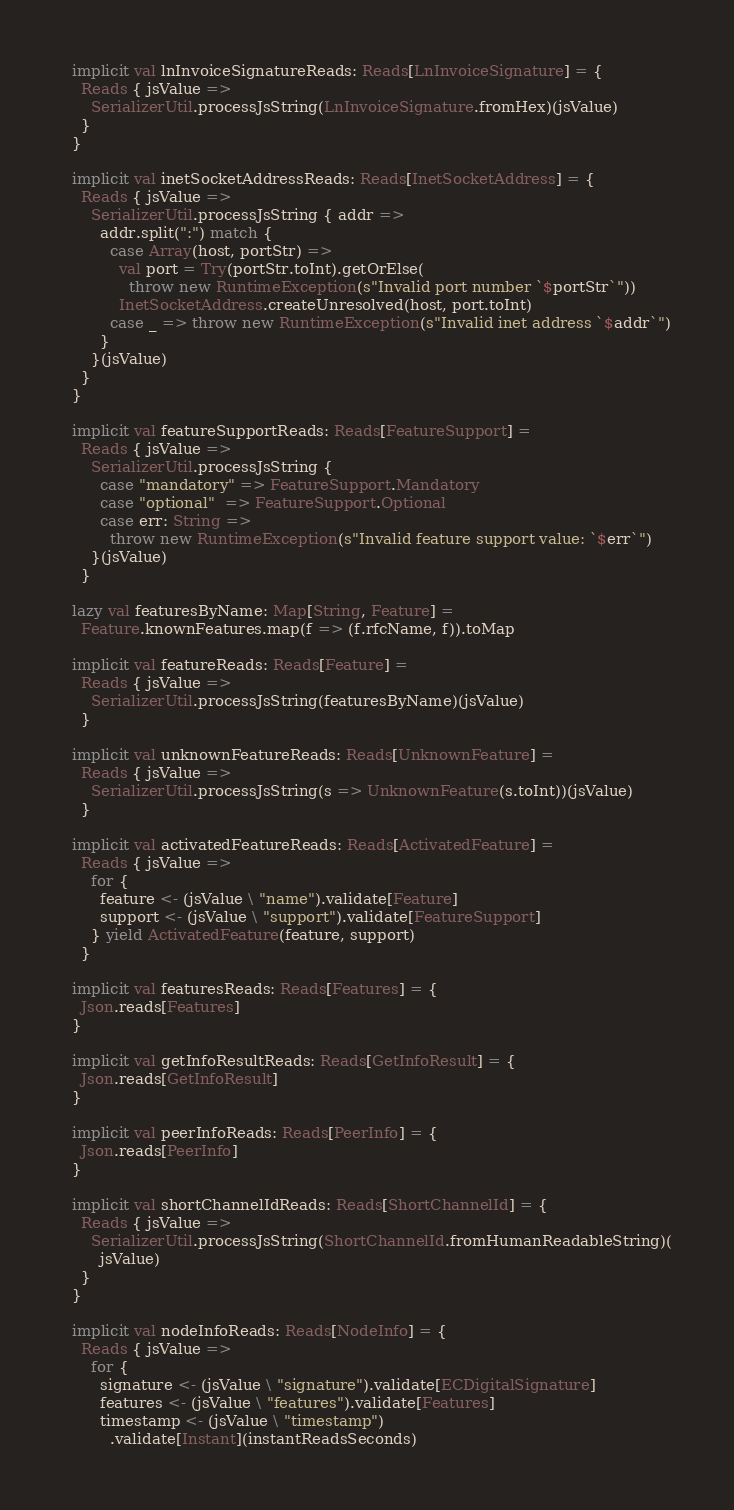Convert code to text. <code><loc_0><loc_0><loc_500><loc_500><_Scala_>
  implicit val lnInvoiceSignatureReads: Reads[LnInvoiceSignature] = {
    Reads { jsValue =>
      SerializerUtil.processJsString(LnInvoiceSignature.fromHex)(jsValue)
    }
  }

  implicit val inetSocketAddressReads: Reads[InetSocketAddress] = {
    Reads { jsValue =>
      SerializerUtil.processJsString { addr =>
        addr.split(":") match {
          case Array(host, portStr) =>
            val port = Try(portStr.toInt).getOrElse(
              throw new RuntimeException(s"Invalid port number `$portStr`"))
            InetSocketAddress.createUnresolved(host, port.toInt)
          case _ => throw new RuntimeException(s"Invalid inet address `$addr`")
        }
      }(jsValue)
    }
  }

  implicit val featureSupportReads: Reads[FeatureSupport] =
    Reads { jsValue =>
      SerializerUtil.processJsString {
        case "mandatory" => FeatureSupport.Mandatory
        case "optional"  => FeatureSupport.Optional
        case err: String =>
          throw new RuntimeException(s"Invalid feature support value: `$err`")
      }(jsValue)
    }

  lazy val featuresByName: Map[String, Feature] =
    Feature.knownFeatures.map(f => (f.rfcName, f)).toMap

  implicit val featureReads: Reads[Feature] =
    Reads { jsValue =>
      SerializerUtil.processJsString(featuresByName)(jsValue)
    }

  implicit val unknownFeatureReads: Reads[UnknownFeature] =
    Reads { jsValue =>
      SerializerUtil.processJsString(s => UnknownFeature(s.toInt))(jsValue)
    }

  implicit val activatedFeatureReads: Reads[ActivatedFeature] =
    Reads { jsValue =>
      for {
        feature <- (jsValue \ "name").validate[Feature]
        support <- (jsValue \ "support").validate[FeatureSupport]
      } yield ActivatedFeature(feature, support)
    }

  implicit val featuresReads: Reads[Features] = {
    Json.reads[Features]
  }

  implicit val getInfoResultReads: Reads[GetInfoResult] = {
    Json.reads[GetInfoResult]
  }

  implicit val peerInfoReads: Reads[PeerInfo] = {
    Json.reads[PeerInfo]
  }

  implicit val shortChannelIdReads: Reads[ShortChannelId] = {
    Reads { jsValue =>
      SerializerUtil.processJsString(ShortChannelId.fromHumanReadableString)(
        jsValue)
    }
  }

  implicit val nodeInfoReads: Reads[NodeInfo] = {
    Reads { jsValue =>
      for {
        signature <- (jsValue \ "signature").validate[ECDigitalSignature]
        features <- (jsValue \ "features").validate[Features]
        timestamp <- (jsValue \ "timestamp")
          .validate[Instant](instantReadsSeconds)</code> 